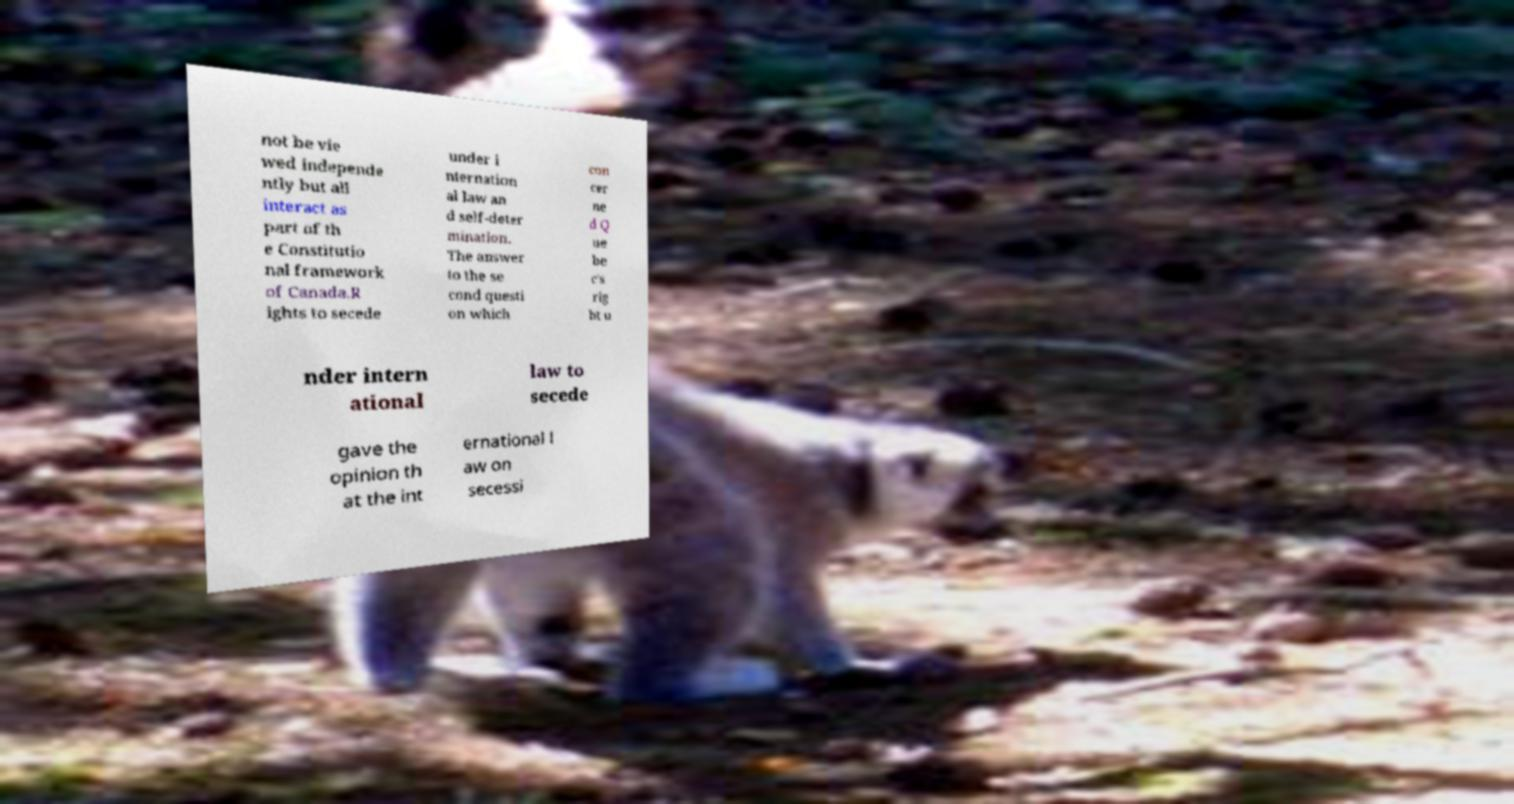Please read and relay the text visible in this image. What does it say? not be vie wed independe ntly but all interact as part of th e Constitutio nal framework of Canada.R ights to secede under i nternation al law an d self-deter mination. The answer to the se cond questi on which con cer ne d Q ue be c's rig ht u nder intern ational law to secede gave the opinion th at the int ernational l aw on secessi 